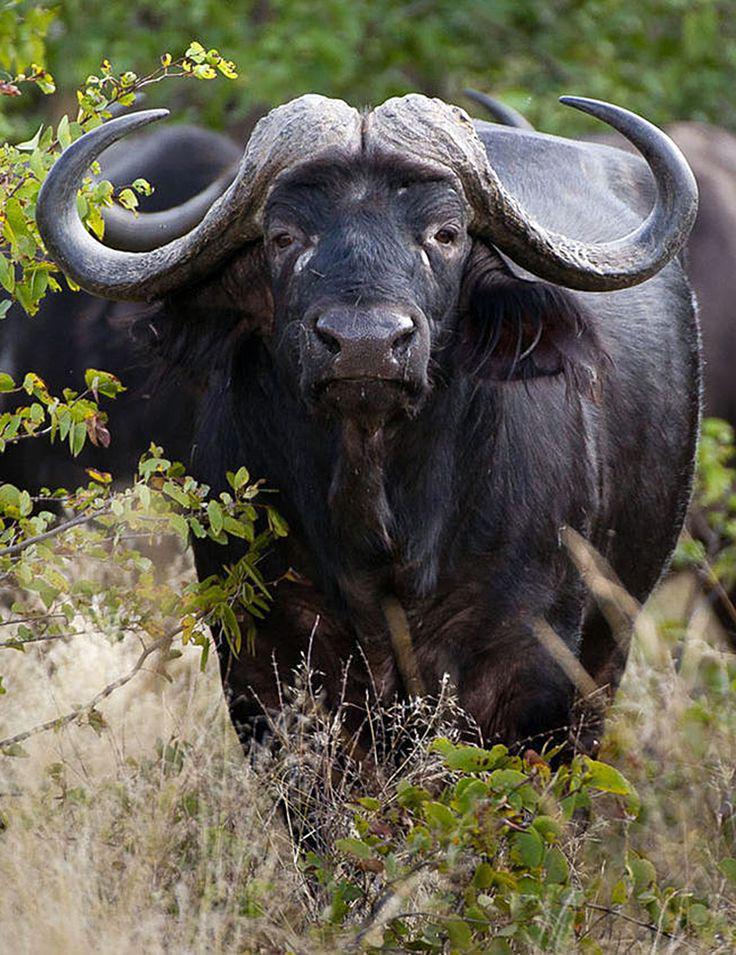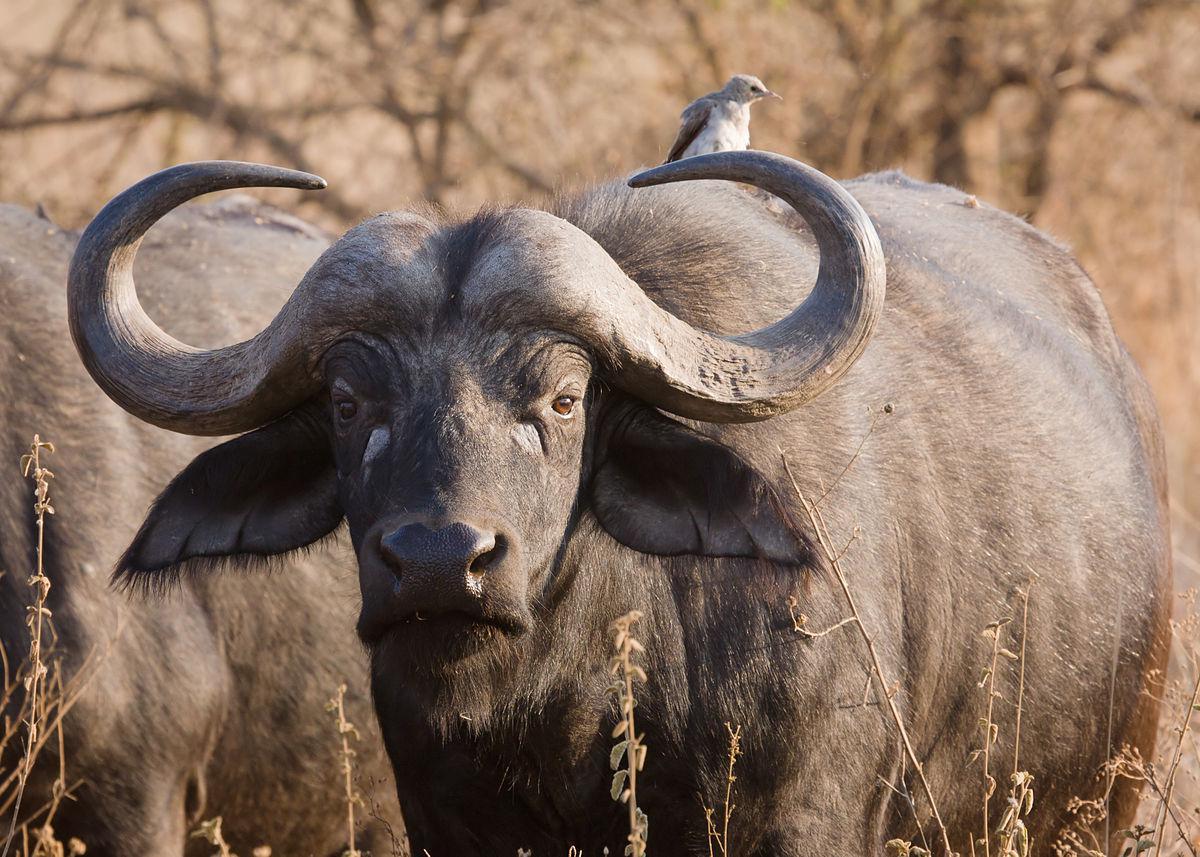The first image is the image on the left, the second image is the image on the right. Considering the images on both sides, is "One image shows at least four water buffalo." valid? Answer yes or no. No. 